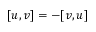Convert formula to latex. <formula><loc_0><loc_0><loc_500><loc_500>[ u , v ] = - [ v , u ]</formula> 